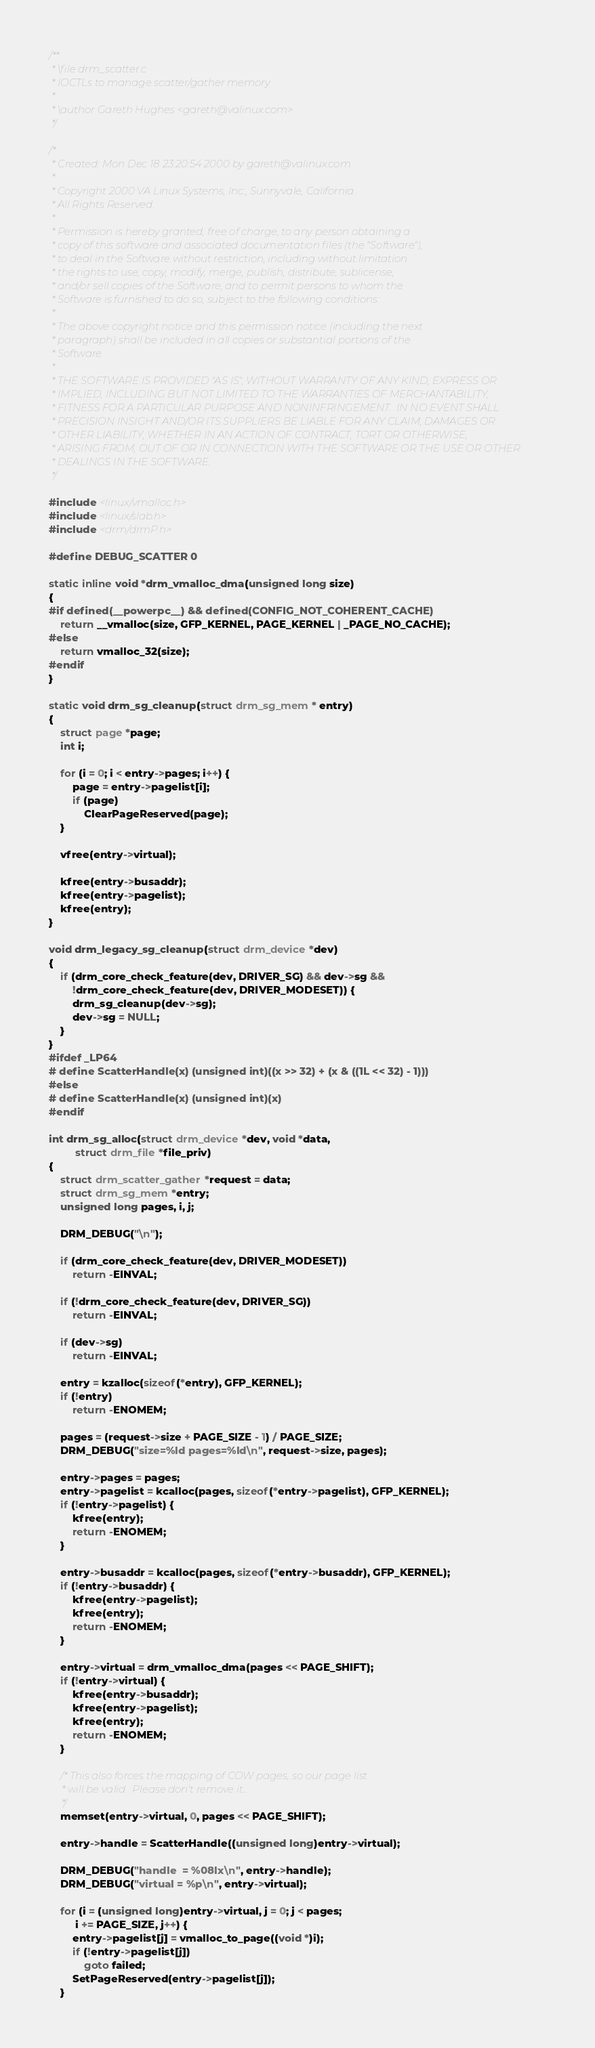<code> <loc_0><loc_0><loc_500><loc_500><_C_>/**
 * \file drm_scatter.c
 * IOCTLs to manage scatter/gather memory
 *
 * \author Gareth Hughes <gareth@valinux.com>
 */

/*
 * Created: Mon Dec 18 23:20:54 2000 by gareth@valinux.com
 *
 * Copyright 2000 VA Linux Systems, Inc., Sunnyvale, California.
 * All Rights Reserved.
 *
 * Permission is hereby granted, free of charge, to any person obtaining a
 * copy of this software and associated documentation files (the "Software"),
 * to deal in the Software without restriction, including without limitation
 * the rights to use, copy, modify, merge, publish, distribute, sublicense,
 * and/or sell copies of the Software, and to permit persons to whom the
 * Software is furnished to do so, subject to the following conditions:
 *
 * The above copyright notice and this permission notice (including the next
 * paragraph) shall be included in all copies or substantial portions of the
 * Software.
 *
 * THE SOFTWARE IS PROVIDED "AS IS", WITHOUT WARRANTY OF ANY KIND, EXPRESS OR
 * IMPLIED, INCLUDING BUT NOT LIMITED TO THE WARRANTIES OF MERCHANTABILITY,
 * FITNESS FOR A PARTICULAR PURPOSE AND NONINFRINGEMENT.  IN NO EVENT SHALL
 * PRECISION INSIGHT AND/OR ITS SUPPLIERS BE LIABLE FOR ANY CLAIM, DAMAGES OR
 * OTHER LIABILITY, WHETHER IN AN ACTION OF CONTRACT, TORT OR OTHERWISE,
 * ARISING FROM, OUT OF OR IN CONNECTION WITH THE SOFTWARE OR THE USE OR OTHER
 * DEALINGS IN THE SOFTWARE.
 */

#include <linux/vmalloc.h>
#include <linux/slab.h>
#include <drm/drmP.h>

#define DEBUG_SCATTER 0

static inline void *drm_vmalloc_dma(unsigned long size)
{
#if defined(__powerpc__) && defined(CONFIG_NOT_COHERENT_CACHE)
	return __vmalloc(size, GFP_KERNEL, PAGE_KERNEL | _PAGE_NO_CACHE);
#else
	return vmalloc_32(size);
#endif
}

static void drm_sg_cleanup(struct drm_sg_mem * entry)
{
	struct page *page;
	int i;

	for (i = 0; i < entry->pages; i++) {
		page = entry->pagelist[i];
		if (page)
			ClearPageReserved(page);
	}

	vfree(entry->virtual);

	kfree(entry->busaddr);
	kfree(entry->pagelist);
	kfree(entry);
}

void drm_legacy_sg_cleanup(struct drm_device *dev)
{
	if (drm_core_check_feature(dev, DRIVER_SG) && dev->sg &&
	    !drm_core_check_feature(dev, DRIVER_MODESET)) {
		drm_sg_cleanup(dev->sg);
		dev->sg = NULL;
	}
}
#ifdef _LP64
# define ScatterHandle(x) (unsigned int)((x >> 32) + (x & ((1L << 32) - 1)))
#else
# define ScatterHandle(x) (unsigned int)(x)
#endif

int drm_sg_alloc(struct drm_device *dev, void *data,
		 struct drm_file *file_priv)
{
	struct drm_scatter_gather *request = data;
	struct drm_sg_mem *entry;
	unsigned long pages, i, j;

	DRM_DEBUG("\n");

	if (drm_core_check_feature(dev, DRIVER_MODESET))
		return -EINVAL;

	if (!drm_core_check_feature(dev, DRIVER_SG))
		return -EINVAL;

	if (dev->sg)
		return -EINVAL;

	entry = kzalloc(sizeof(*entry), GFP_KERNEL);
	if (!entry)
		return -ENOMEM;

	pages = (request->size + PAGE_SIZE - 1) / PAGE_SIZE;
	DRM_DEBUG("size=%ld pages=%ld\n", request->size, pages);

	entry->pages = pages;
	entry->pagelist = kcalloc(pages, sizeof(*entry->pagelist), GFP_KERNEL);
	if (!entry->pagelist) {
		kfree(entry);
		return -ENOMEM;
	}

	entry->busaddr = kcalloc(pages, sizeof(*entry->busaddr), GFP_KERNEL);
	if (!entry->busaddr) {
		kfree(entry->pagelist);
		kfree(entry);
		return -ENOMEM;
	}

	entry->virtual = drm_vmalloc_dma(pages << PAGE_SHIFT);
	if (!entry->virtual) {
		kfree(entry->busaddr);
		kfree(entry->pagelist);
		kfree(entry);
		return -ENOMEM;
	}

	/* This also forces the mapping of COW pages, so our page list
	 * will be valid.  Please don't remove it...
	 */
	memset(entry->virtual, 0, pages << PAGE_SHIFT);

	entry->handle = ScatterHandle((unsigned long)entry->virtual);

	DRM_DEBUG("handle  = %08lx\n", entry->handle);
	DRM_DEBUG("virtual = %p\n", entry->virtual);

	for (i = (unsigned long)entry->virtual, j = 0; j < pages;
	     i += PAGE_SIZE, j++) {
		entry->pagelist[j] = vmalloc_to_page((void *)i);
		if (!entry->pagelist[j])
			goto failed;
		SetPageReserved(entry->pagelist[j]);
	}
</code> 